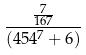<formula> <loc_0><loc_0><loc_500><loc_500>\frac { \frac { 7 } { 1 6 7 } } { ( 4 5 4 ^ { 7 } + 6 ) }</formula> 